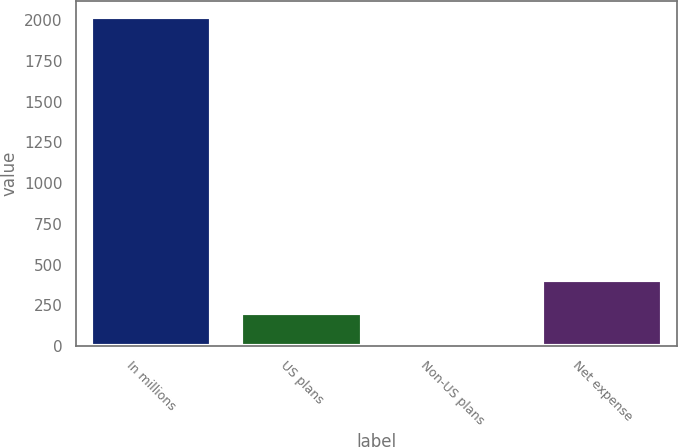Convert chart. <chart><loc_0><loc_0><loc_500><loc_500><bar_chart><fcel>In millions<fcel>US plans<fcel>Non-US plans<fcel>Net expense<nl><fcel>2019<fcel>205.5<fcel>4<fcel>407<nl></chart> 